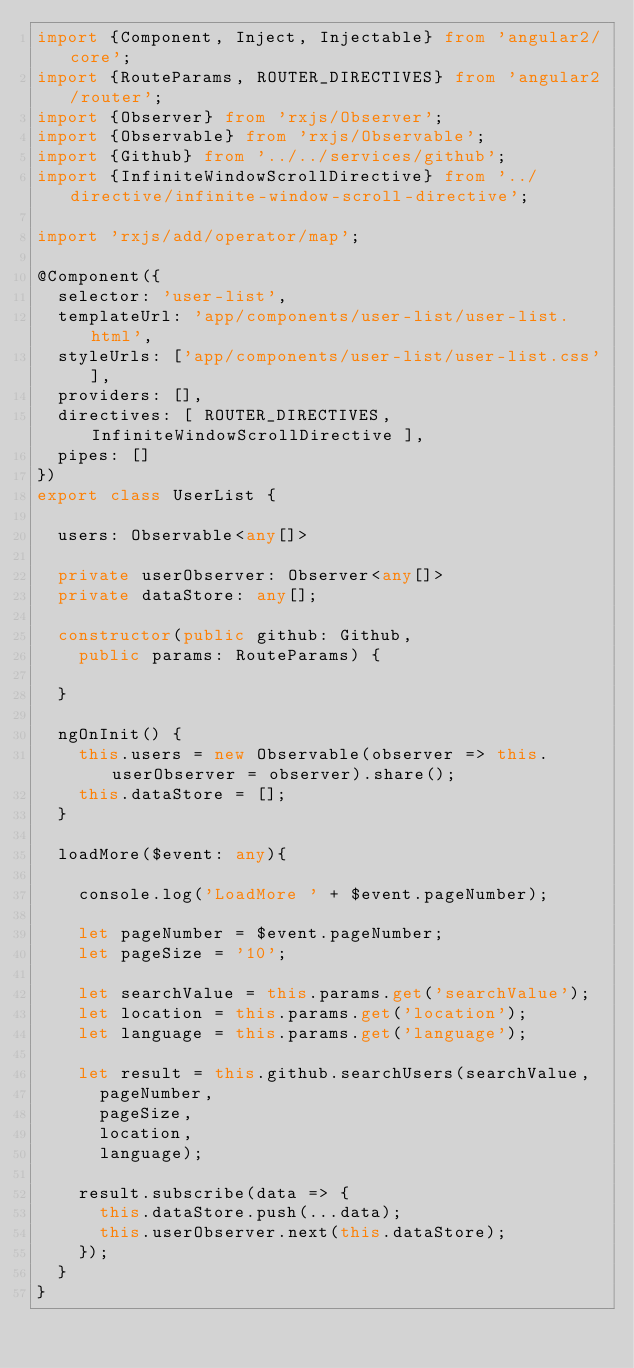Convert code to text. <code><loc_0><loc_0><loc_500><loc_500><_TypeScript_>import {Component, Inject, Injectable} from 'angular2/core';
import {RouteParams, ROUTER_DIRECTIVES} from 'angular2/router';
import {Observer} from 'rxjs/Observer';
import {Observable} from 'rxjs/Observable';
import {Github} from '../../services/github';
import {InfiniteWindowScrollDirective} from '../directive/infinite-window-scroll-directive';

import 'rxjs/add/operator/map';

@Component({
  selector: 'user-list',
  templateUrl: 'app/components/user-list/user-list.html',
  styleUrls: ['app/components/user-list/user-list.css'],
  providers: [],
  directives: [ ROUTER_DIRECTIVES, InfiniteWindowScrollDirective ],
  pipes: []
})
export class UserList {
  
  users: Observable<any[]>
    
  private userObserver: Observer<any[]> 
  private dataStore: any[];
    
  constructor(public github: Github, 
    public params: RouteParams) {

  }
  
  ngOnInit() {
    this.users = new Observable(observer => this.userObserver = observer).share();
    this.dataStore = [];
  }
  
  loadMore($event: any){
   
    console.log('LoadMore ' + $event.pageNumber);

    let pageNumber = $event.pageNumber;
    let pageSize = '10';
      
    let searchValue = this.params.get('searchValue');
    let location = this.params.get('location');
    let language = this.params.get('language');
      
    let result = this.github.searchUsers(searchValue,
      pageNumber,
      pageSize,
      location,
      language);
      
    result.subscribe(data => {      
      this.dataStore.push(...data);
      this.userObserver.next(this.dataStore);  
    });
  }  
}</code> 